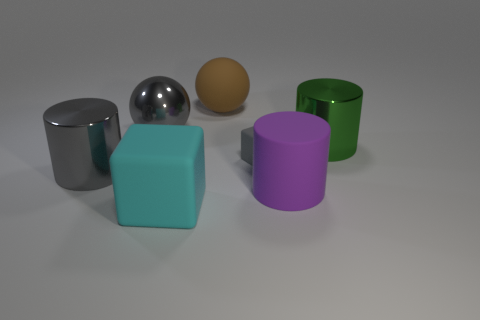Subtract all gray cylinders. How many cylinders are left? 2 Subtract 1 cubes. How many cubes are left? 1 Add 1 tiny red metal spheres. How many objects exist? 8 Subtract all gray cylinders. How many cylinders are left? 2 Subtract all cylinders. How many objects are left? 4 Add 2 purple metallic objects. How many purple metallic objects exist? 2 Subtract 1 purple cylinders. How many objects are left? 6 Subtract all red cylinders. Subtract all yellow balls. How many cylinders are left? 3 Subtract all purple cubes. How many red cylinders are left? 0 Subtract all tiny red spheres. Subtract all big purple rubber cylinders. How many objects are left? 6 